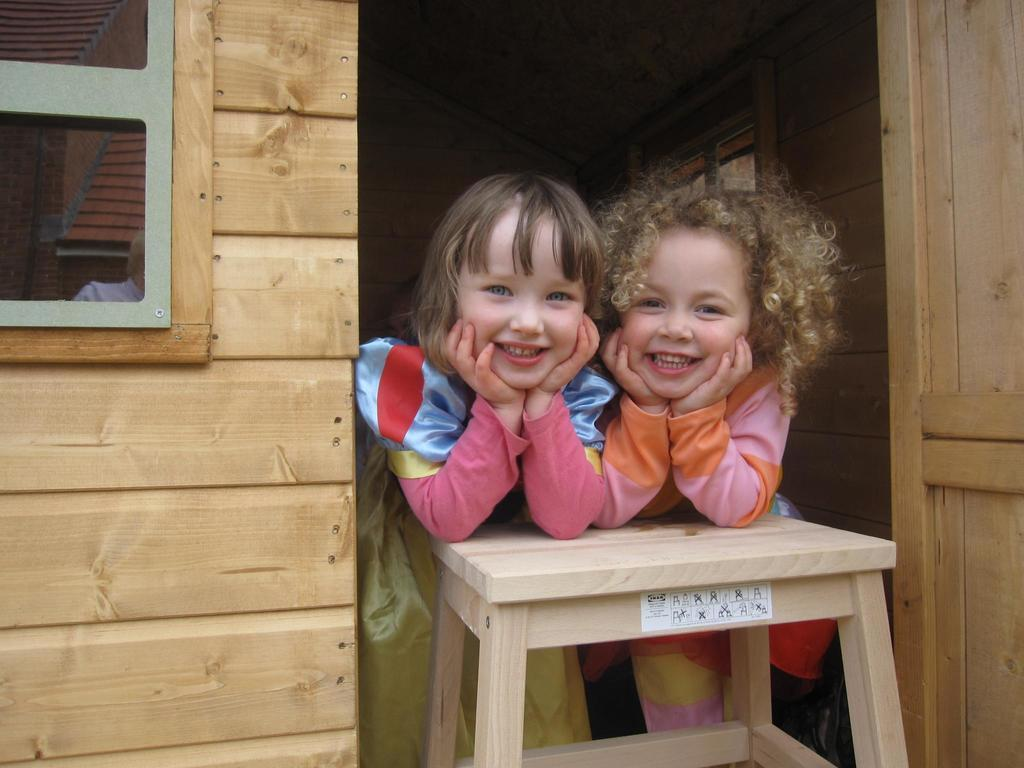How many people are in the image? There are two girls in the image. What is the facial expression of the girls? The girls are smiling. What object are the girls touching in the image? The girls have placed their hands on a stool. What can be seen in the background of the image? There is a wall in the background of the image. What type of string can be seen connecting the girls in the image? There is no string connecting the girls in the image. 